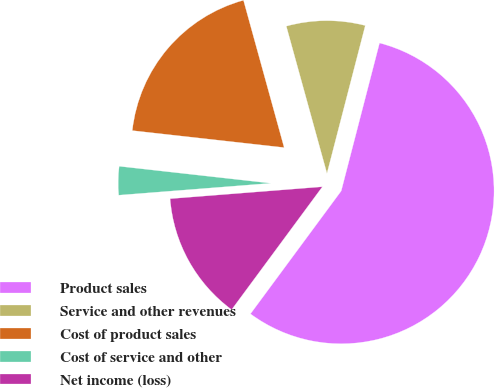<chart> <loc_0><loc_0><loc_500><loc_500><pie_chart><fcel>Product sales<fcel>Service and other revenues<fcel>Cost of product sales<fcel>Cost of service and other<fcel>Net income (loss)<nl><fcel>56.09%<fcel>8.32%<fcel>18.94%<fcel>3.02%<fcel>13.63%<nl></chart> 